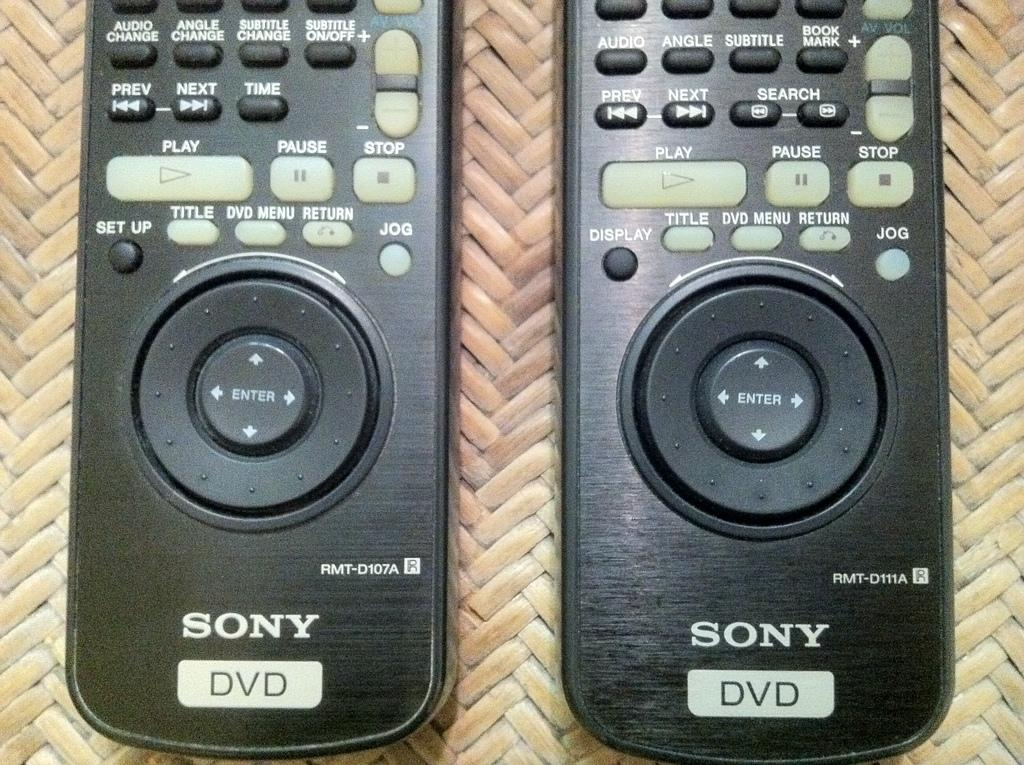<image>
Relay a brief, clear account of the picture shown. A pair of identical Sony DVD remote controls sit on a mat. 